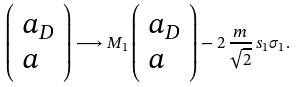<formula> <loc_0><loc_0><loc_500><loc_500>\left ( \begin{array} { l } { { a _ { D } } } \\ { a } \end{array} \right ) \longrightarrow M _ { 1 } \left ( \begin{array} { l } { { a _ { D } } } \\ { a } \end{array} \right ) - 2 \, { \frac { m } { \sqrt { 2 } } } \, s _ { 1 } \sigma _ { 1 } .</formula> 